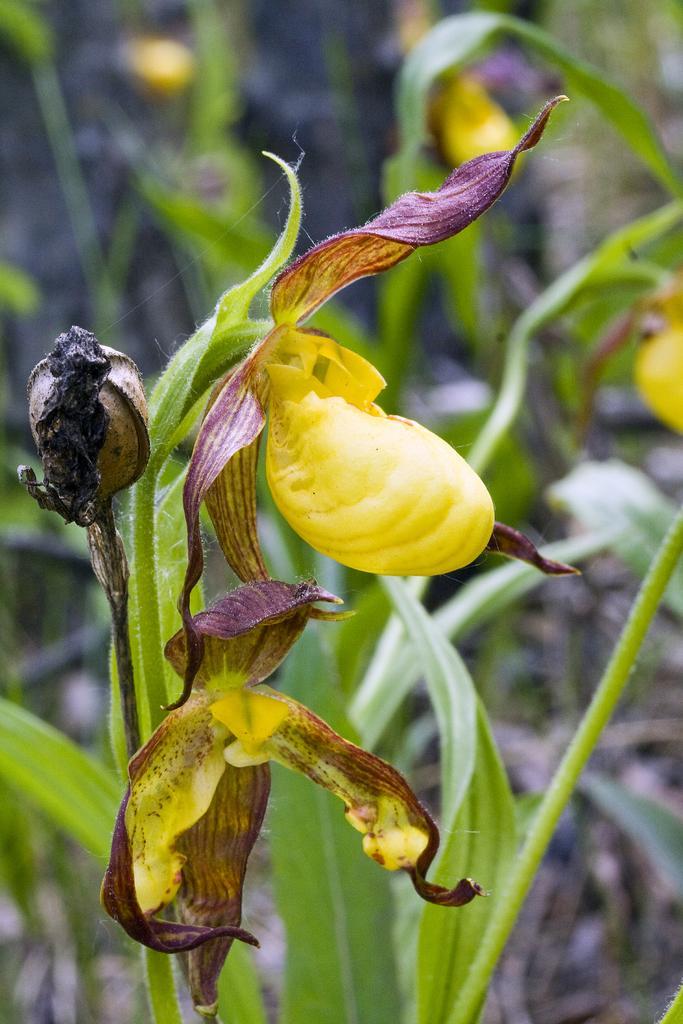Describe this image in one or two sentences. This image is taken outdoors. In the background there are few plants. In the middle of the image there is a plant with a bud and two flowers which are yellow in color. 